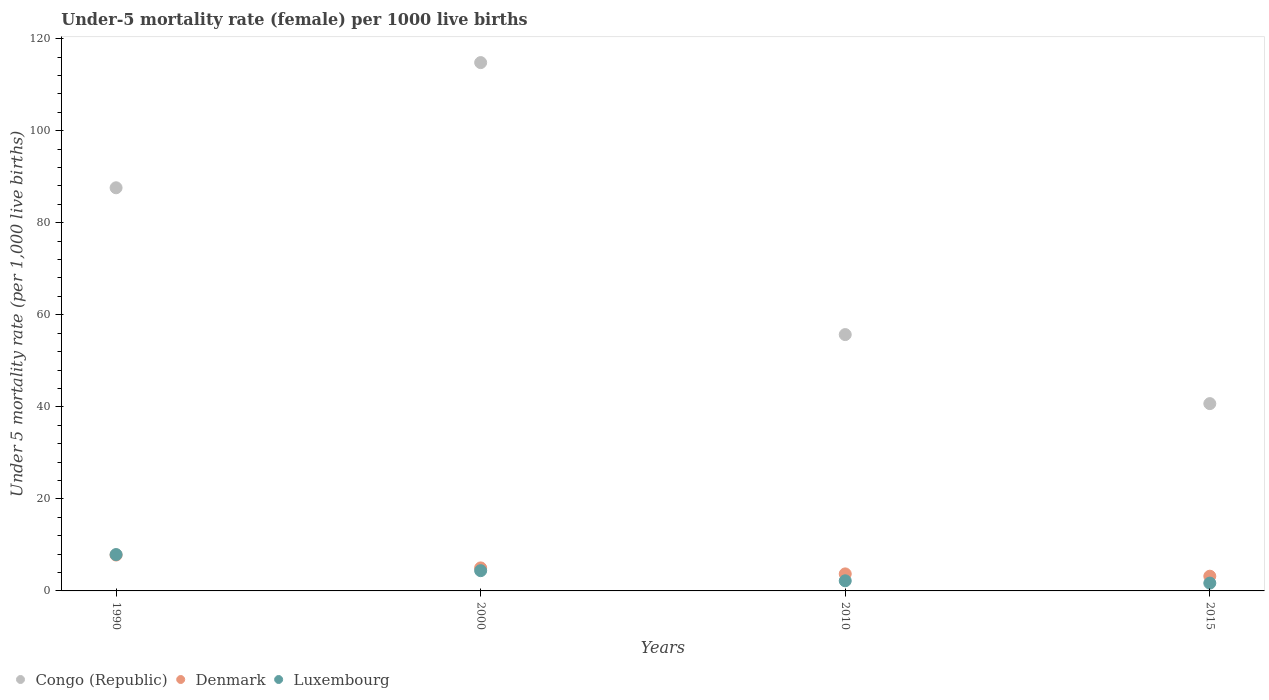How many different coloured dotlines are there?
Offer a terse response. 3. What is the under-five mortality rate in Congo (Republic) in 1990?
Your answer should be very brief. 87.6. Across all years, what is the maximum under-five mortality rate in Luxembourg?
Make the answer very short. 7.9. Across all years, what is the minimum under-five mortality rate in Luxembourg?
Make the answer very short. 1.7. In which year was the under-five mortality rate in Denmark maximum?
Make the answer very short. 1990. In which year was the under-five mortality rate in Luxembourg minimum?
Your answer should be compact. 2015. What is the total under-five mortality rate in Luxembourg in the graph?
Your answer should be very brief. 16.2. What is the difference between the under-five mortality rate in Denmark in 2000 and that in 2010?
Your answer should be very brief. 1.3. What is the difference between the under-five mortality rate in Luxembourg in 2000 and the under-five mortality rate in Denmark in 1990?
Offer a very short reply. -3.4. What is the average under-five mortality rate in Congo (Republic) per year?
Give a very brief answer. 74.7. In how many years, is the under-five mortality rate in Denmark greater than 12?
Offer a very short reply. 0. What is the ratio of the under-five mortality rate in Luxembourg in 2010 to that in 2015?
Your answer should be very brief. 1.29. Is the under-five mortality rate in Congo (Republic) in 1990 less than that in 2000?
Your answer should be compact. Yes. Is the difference between the under-five mortality rate in Denmark in 1990 and 2015 greater than the difference between the under-five mortality rate in Luxembourg in 1990 and 2015?
Make the answer very short. No. What is the difference between the highest and the second highest under-five mortality rate in Congo (Republic)?
Give a very brief answer. 27.2. What is the difference between the highest and the lowest under-five mortality rate in Luxembourg?
Ensure brevity in your answer.  6.2. In how many years, is the under-five mortality rate in Congo (Republic) greater than the average under-five mortality rate in Congo (Republic) taken over all years?
Provide a short and direct response. 2. Is the sum of the under-five mortality rate in Denmark in 1990 and 2015 greater than the maximum under-five mortality rate in Congo (Republic) across all years?
Your answer should be very brief. No. Is it the case that in every year, the sum of the under-five mortality rate in Denmark and under-five mortality rate in Luxembourg  is greater than the under-five mortality rate in Congo (Republic)?
Offer a very short reply. No. Is the under-five mortality rate in Congo (Republic) strictly greater than the under-five mortality rate in Luxembourg over the years?
Your response must be concise. Yes. Does the graph contain grids?
Offer a terse response. No. How many legend labels are there?
Your answer should be very brief. 3. How are the legend labels stacked?
Make the answer very short. Horizontal. What is the title of the graph?
Provide a succinct answer. Under-5 mortality rate (female) per 1000 live births. What is the label or title of the X-axis?
Offer a very short reply. Years. What is the label or title of the Y-axis?
Provide a short and direct response. Under 5 mortality rate (per 1,0 live births). What is the Under 5 mortality rate (per 1,000 live births) of Congo (Republic) in 1990?
Make the answer very short. 87.6. What is the Under 5 mortality rate (per 1,000 live births) of Denmark in 1990?
Your response must be concise. 7.8. What is the Under 5 mortality rate (per 1,000 live births) of Congo (Republic) in 2000?
Keep it short and to the point. 114.8. What is the Under 5 mortality rate (per 1,000 live births) of Luxembourg in 2000?
Your answer should be compact. 4.4. What is the Under 5 mortality rate (per 1,000 live births) in Congo (Republic) in 2010?
Provide a short and direct response. 55.7. What is the Under 5 mortality rate (per 1,000 live births) of Congo (Republic) in 2015?
Provide a succinct answer. 40.7. What is the Under 5 mortality rate (per 1,000 live births) of Luxembourg in 2015?
Give a very brief answer. 1.7. Across all years, what is the maximum Under 5 mortality rate (per 1,000 live births) of Congo (Republic)?
Make the answer very short. 114.8. Across all years, what is the maximum Under 5 mortality rate (per 1,000 live births) of Luxembourg?
Ensure brevity in your answer.  7.9. Across all years, what is the minimum Under 5 mortality rate (per 1,000 live births) in Congo (Republic)?
Your answer should be compact. 40.7. Across all years, what is the minimum Under 5 mortality rate (per 1,000 live births) of Denmark?
Give a very brief answer. 3.2. Across all years, what is the minimum Under 5 mortality rate (per 1,000 live births) in Luxembourg?
Your response must be concise. 1.7. What is the total Under 5 mortality rate (per 1,000 live births) of Congo (Republic) in the graph?
Keep it short and to the point. 298.8. What is the total Under 5 mortality rate (per 1,000 live births) in Luxembourg in the graph?
Your answer should be very brief. 16.2. What is the difference between the Under 5 mortality rate (per 1,000 live births) in Congo (Republic) in 1990 and that in 2000?
Provide a short and direct response. -27.2. What is the difference between the Under 5 mortality rate (per 1,000 live births) of Luxembourg in 1990 and that in 2000?
Give a very brief answer. 3.5. What is the difference between the Under 5 mortality rate (per 1,000 live births) in Congo (Republic) in 1990 and that in 2010?
Make the answer very short. 31.9. What is the difference between the Under 5 mortality rate (per 1,000 live births) of Denmark in 1990 and that in 2010?
Provide a succinct answer. 4.1. What is the difference between the Under 5 mortality rate (per 1,000 live births) of Congo (Republic) in 1990 and that in 2015?
Your answer should be very brief. 46.9. What is the difference between the Under 5 mortality rate (per 1,000 live births) of Luxembourg in 1990 and that in 2015?
Provide a succinct answer. 6.2. What is the difference between the Under 5 mortality rate (per 1,000 live births) in Congo (Republic) in 2000 and that in 2010?
Give a very brief answer. 59.1. What is the difference between the Under 5 mortality rate (per 1,000 live births) in Luxembourg in 2000 and that in 2010?
Make the answer very short. 2.2. What is the difference between the Under 5 mortality rate (per 1,000 live births) of Congo (Republic) in 2000 and that in 2015?
Give a very brief answer. 74.1. What is the difference between the Under 5 mortality rate (per 1,000 live births) in Luxembourg in 2000 and that in 2015?
Ensure brevity in your answer.  2.7. What is the difference between the Under 5 mortality rate (per 1,000 live births) in Congo (Republic) in 2010 and that in 2015?
Ensure brevity in your answer.  15. What is the difference between the Under 5 mortality rate (per 1,000 live births) in Luxembourg in 2010 and that in 2015?
Ensure brevity in your answer.  0.5. What is the difference between the Under 5 mortality rate (per 1,000 live births) of Congo (Republic) in 1990 and the Under 5 mortality rate (per 1,000 live births) of Denmark in 2000?
Your answer should be very brief. 82.6. What is the difference between the Under 5 mortality rate (per 1,000 live births) in Congo (Republic) in 1990 and the Under 5 mortality rate (per 1,000 live births) in Luxembourg in 2000?
Ensure brevity in your answer.  83.2. What is the difference between the Under 5 mortality rate (per 1,000 live births) in Denmark in 1990 and the Under 5 mortality rate (per 1,000 live births) in Luxembourg in 2000?
Your response must be concise. 3.4. What is the difference between the Under 5 mortality rate (per 1,000 live births) in Congo (Republic) in 1990 and the Under 5 mortality rate (per 1,000 live births) in Denmark in 2010?
Keep it short and to the point. 83.9. What is the difference between the Under 5 mortality rate (per 1,000 live births) in Congo (Republic) in 1990 and the Under 5 mortality rate (per 1,000 live births) in Luxembourg in 2010?
Your answer should be compact. 85.4. What is the difference between the Under 5 mortality rate (per 1,000 live births) of Denmark in 1990 and the Under 5 mortality rate (per 1,000 live births) of Luxembourg in 2010?
Offer a terse response. 5.6. What is the difference between the Under 5 mortality rate (per 1,000 live births) of Congo (Republic) in 1990 and the Under 5 mortality rate (per 1,000 live births) of Denmark in 2015?
Offer a very short reply. 84.4. What is the difference between the Under 5 mortality rate (per 1,000 live births) in Congo (Republic) in 1990 and the Under 5 mortality rate (per 1,000 live births) in Luxembourg in 2015?
Your answer should be compact. 85.9. What is the difference between the Under 5 mortality rate (per 1,000 live births) of Congo (Republic) in 2000 and the Under 5 mortality rate (per 1,000 live births) of Denmark in 2010?
Your response must be concise. 111.1. What is the difference between the Under 5 mortality rate (per 1,000 live births) in Congo (Republic) in 2000 and the Under 5 mortality rate (per 1,000 live births) in Luxembourg in 2010?
Provide a succinct answer. 112.6. What is the difference between the Under 5 mortality rate (per 1,000 live births) in Congo (Republic) in 2000 and the Under 5 mortality rate (per 1,000 live births) in Denmark in 2015?
Keep it short and to the point. 111.6. What is the difference between the Under 5 mortality rate (per 1,000 live births) of Congo (Republic) in 2000 and the Under 5 mortality rate (per 1,000 live births) of Luxembourg in 2015?
Provide a short and direct response. 113.1. What is the difference between the Under 5 mortality rate (per 1,000 live births) in Denmark in 2000 and the Under 5 mortality rate (per 1,000 live births) in Luxembourg in 2015?
Offer a very short reply. 3.3. What is the difference between the Under 5 mortality rate (per 1,000 live births) of Congo (Republic) in 2010 and the Under 5 mortality rate (per 1,000 live births) of Denmark in 2015?
Your answer should be very brief. 52.5. What is the difference between the Under 5 mortality rate (per 1,000 live births) of Congo (Republic) in 2010 and the Under 5 mortality rate (per 1,000 live births) of Luxembourg in 2015?
Provide a short and direct response. 54. What is the difference between the Under 5 mortality rate (per 1,000 live births) in Denmark in 2010 and the Under 5 mortality rate (per 1,000 live births) in Luxembourg in 2015?
Provide a succinct answer. 2. What is the average Under 5 mortality rate (per 1,000 live births) of Congo (Republic) per year?
Keep it short and to the point. 74.7. What is the average Under 5 mortality rate (per 1,000 live births) in Denmark per year?
Provide a short and direct response. 4.92. What is the average Under 5 mortality rate (per 1,000 live births) of Luxembourg per year?
Offer a very short reply. 4.05. In the year 1990, what is the difference between the Under 5 mortality rate (per 1,000 live births) of Congo (Republic) and Under 5 mortality rate (per 1,000 live births) of Denmark?
Your answer should be compact. 79.8. In the year 1990, what is the difference between the Under 5 mortality rate (per 1,000 live births) of Congo (Republic) and Under 5 mortality rate (per 1,000 live births) of Luxembourg?
Your response must be concise. 79.7. In the year 1990, what is the difference between the Under 5 mortality rate (per 1,000 live births) of Denmark and Under 5 mortality rate (per 1,000 live births) of Luxembourg?
Your response must be concise. -0.1. In the year 2000, what is the difference between the Under 5 mortality rate (per 1,000 live births) in Congo (Republic) and Under 5 mortality rate (per 1,000 live births) in Denmark?
Make the answer very short. 109.8. In the year 2000, what is the difference between the Under 5 mortality rate (per 1,000 live births) in Congo (Republic) and Under 5 mortality rate (per 1,000 live births) in Luxembourg?
Keep it short and to the point. 110.4. In the year 2000, what is the difference between the Under 5 mortality rate (per 1,000 live births) in Denmark and Under 5 mortality rate (per 1,000 live births) in Luxembourg?
Provide a short and direct response. 0.6. In the year 2010, what is the difference between the Under 5 mortality rate (per 1,000 live births) of Congo (Republic) and Under 5 mortality rate (per 1,000 live births) of Luxembourg?
Offer a very short reply. 53.5. In the year 2010, what is the difference between the Under 5 mortality rate (per 1,000 live births) of Denmark and Under 5 mortality rate (per 1,000 live births) of Luxembourg?
Ensure brevity in your answer.  1.5. In the year 2015, what is the difference between the Under 5 mortality rate (per 1,000 live births) of Congo (Republic) and Under 5 mortality rate (per 1,000 live births) of Denmark?
Provide a short and direct response. 37.5. In the year 2015, what is the difference between the Under 5 mortality rate (per 1,000 live births) of Denmark and Under 5 mortality rate (per 1,000 live births) of Luxembourg?
Your response must be concise. 1.5. What is the ratio of the Under 5 mortality rate (per 1,000 live births) of Congo (Republic) in 1990 to that in 2000?
Your answer should be compact. 0.76. What is the ratio of the Under 5 mortality rate (per 1,000 live births) of Denmark in 1990 to that in 2000?
Your answer should be very brief. 1.56. What is the ratio of the Under 5 mortality rate (per 1,000 live births) in Luxembourg in 1990 to that in 2000?
Your answer should be very brief. 1.8. What is the ratio of the Under 5 mortality rate (per 1,000 live births) of Congo (Republic) in 1990 to that in 2010?
Your response must be concise. 1.57. What is the ratio of the Under 5 mortality rate (per 1,000 live births) in Denmark in 1990 to that in 2010?
Your response must be concise. 2.11. What is the ratio of the Under 5 mortality rate (per 1,000 live births) of Luxembourg in 1990 to that in 2010?
Make the answer very short. 3.59. What is the ratio of the Under 5 mortality rate (per 1,000 live births) of Congo (Republic) in 1990 to that in 2015?
Ensure brevity in your answer.  2.15. What is the ratio of the Under 5 mortality rate (per 1,000 live births) of Denmark in 1990 to that in 2015?
Make the answer very short. 2.44. What is the ratio of the Under 5 mortality rate (per 1,000 live births) in Luxembourg in 1990 to that in 2015?
Offer a very short reply. 4.65. What is the ratio of the Under 5 mortality rate (per 1,000 live births) of Congo (Republic) in 2000 to that in 2010?
Ensure brevity in your answer.  2.06. What is the ratio of the Under 5 mortality rate (per 1,000 live births) in Denmark in 2000 to that in 2010?
Your answer should be very brief. 1.35. What is the ratio of the Under 5 mortality rate (per 1,000 live births) of Luxembourg in 2000 to that in 2010?
Ensure brevity in your answer.  2. What is the ratio of the Under 5 mortality rate (per 1,000 live births) of Congo (Republic) in 2000 to that in 2015?
Your answer should be compact. 2.82. What is the ratio of the Under 5 mortality rate (per 1,000 live births) of Denmark in 2000 to that in 2015?
Provide a short and direct response. 1.56. What is the ratio of the Under 5 mortality rate (per 1,000 live births) in Luxembourg in 2000 to that in 2015?
Keep it short and to the point. 2.59. What is the ratio of the Under 5 mortality rate (per 1,000 live births) in Congo (Republic) in 2010 to that in 2015?
Keep it short and to the point. 1.37. What is the ratio of the Under 5 mortality rate (per 1,000 live births) in Denmark in 2010 to that in 2015?
Your answer should be very brief. 1.16. What is the ratio of the Under 5 mortality rate (per 1,000 live births) of Luxembourg in 2010 to that in 2015?
Give a very brief answer. 1.29. What is the difference between the highest and the second highest Under 5 mortality rate (per 1,000 live births) in Congo (Republic)?
Provide a succinct answer. 27.2. What is the difference between the highest and the second highest Under 5 mortality rate (per 1,000 live births) of Denmark?
Keep it short and to the point. 2.8. What is the difference between the highest and the second highest Under 5 mortality rate (per 1,000 live births) of Luxembourg?
Keep it short and to the point. 3.5. What is the difference between the highest and the lowest Under 5 mortality rate (per 1,000 live births) in Congo (Republic)?
Provide a succinct answer. 74.1. 